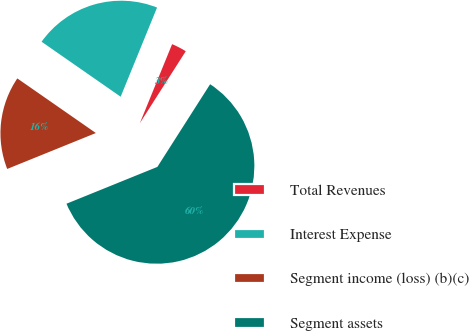Convert chart. <chart><loc_0><loc_0><loc_500><loc_500><pie_chart><fcel>Total Revenues<fcel>Interest Expense<fcel>Segment income (loss) (b)(c)<fcel>Segment assets<nl><fcel>2.87%<fcel>21.5%<fcel>15.8%<fcel>59.84%<nl></chart> 